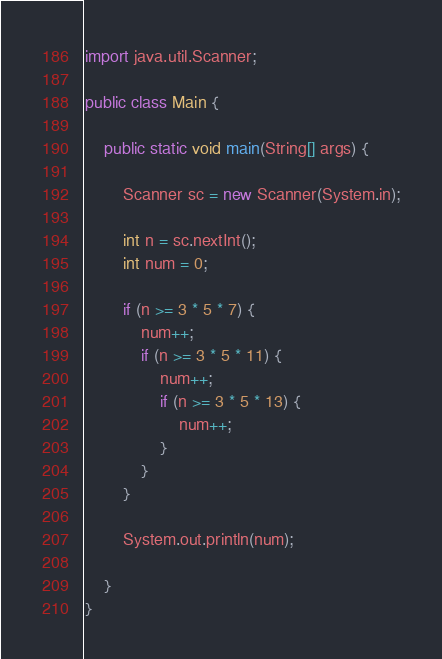Convert code to text. <code><loc_0><loc_0><loc_500><loc_500><_Java_>import java.util.Scanner;

public class Main {

	public static void main(String[] args) {

		Scanner sc = new Scanner(System.in);

		int n = sc.nextInt();
		int num = 0;

		if (n >= 3 * 5 * 7) {
			num++;
			if (n >= 3 * 5 * 11) {
				num++;
				if (n >= 3 * 5 * 13) {
					num++;
				}
			}
		}

		System.out.println(num);

	}
}</code> 